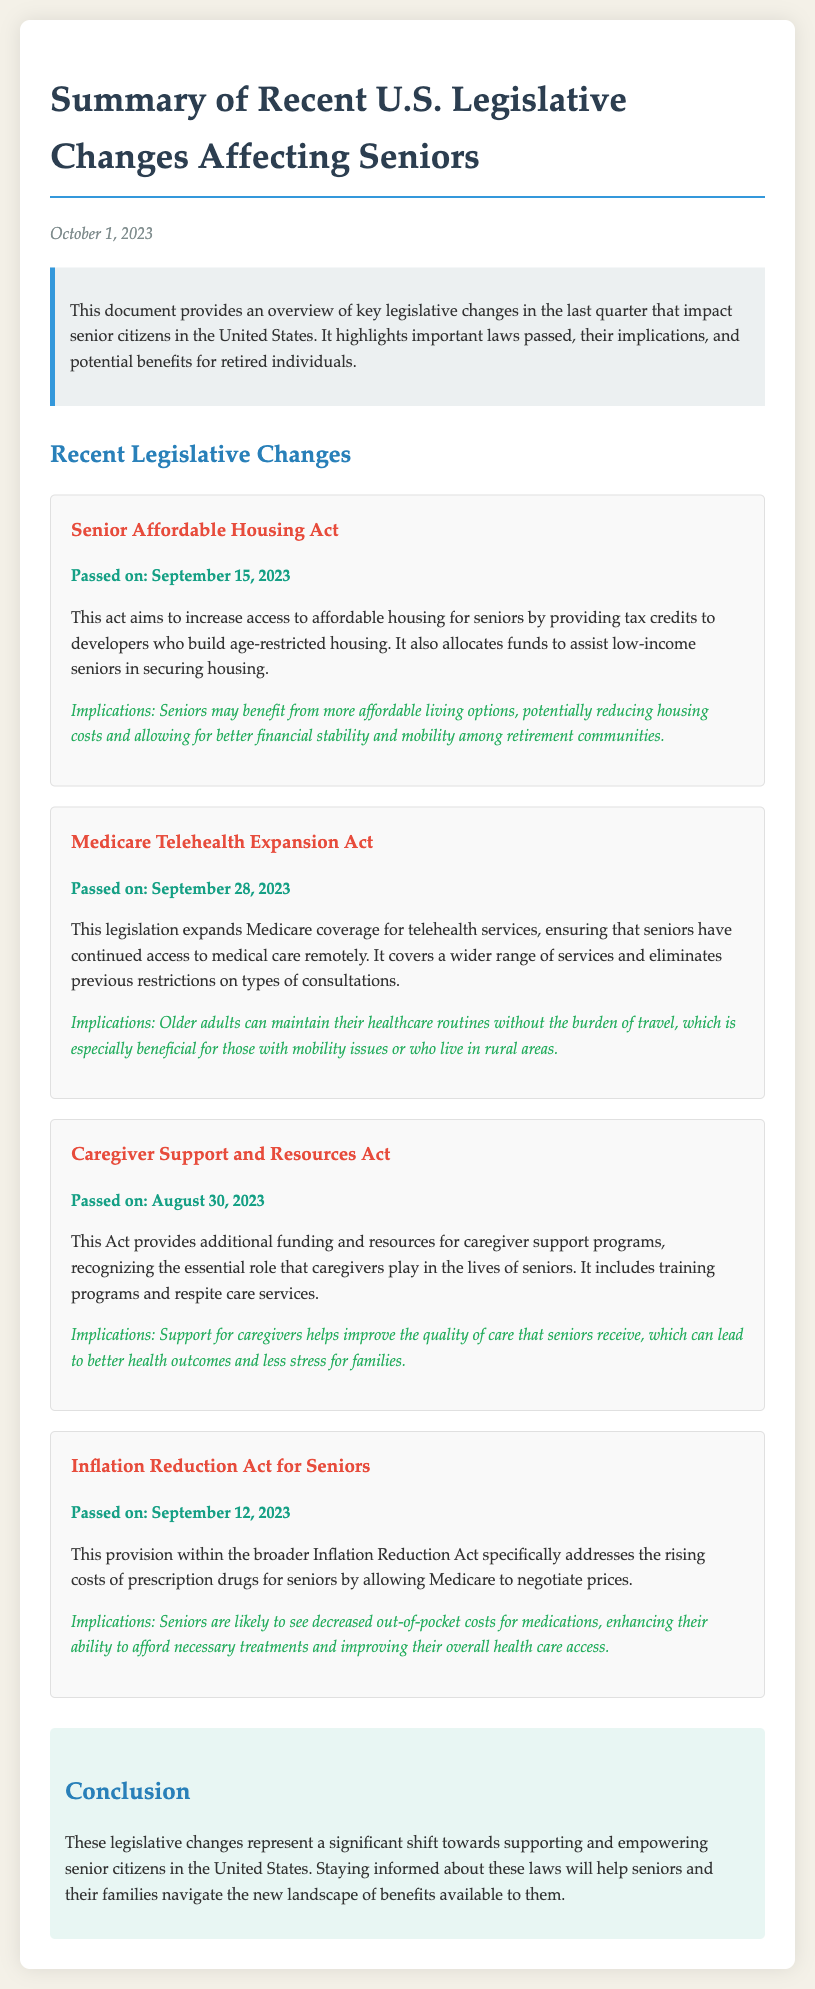What is the title of the document? The title refers to the main subject of the document, which highlights legislative changes impacting seniors.
Answer: Summary of Recent U.S. Legislative Changes Affecting Seniors When was the Senior Affordable Housing Act passed? The date when a specific act was approved is provided within the document.
Answer: September 15, 2023 What does the Medicare Telehealth Expansion Act expand? This act's focus is detailed in the document concerning a particular aspect of healthcare coverage.
Answer: Medicare coverage for telehealth services What type of support does the Caregiver Support and Resources Act provide? The document describes the primary aim of this legislation as it relates to caregiver support.
Answer: Additional funding and resources What is one implication of the Inflation Reduction Act for Seniors? The document discusses the potential effects of the act on seniors, specifically regarding one area.
Answer: Decreased out-of-pocket costs for medications What is the date of the document's publication? The publication date provides a timestamp for the document's relevance.
Answer: October 1, 2023 What was allocated by the Senior Affordable Housing Act? The document mentions a specific allocation related to housing assistance for seniors.
Answer: Funds to assist low-income seniors What is the significance of the recent legislative changes according to the conclusion? The conclusion summarizes the overall impact of the new legislation on a particular demographic.
Answer: Supporting and empowering senior citizens 